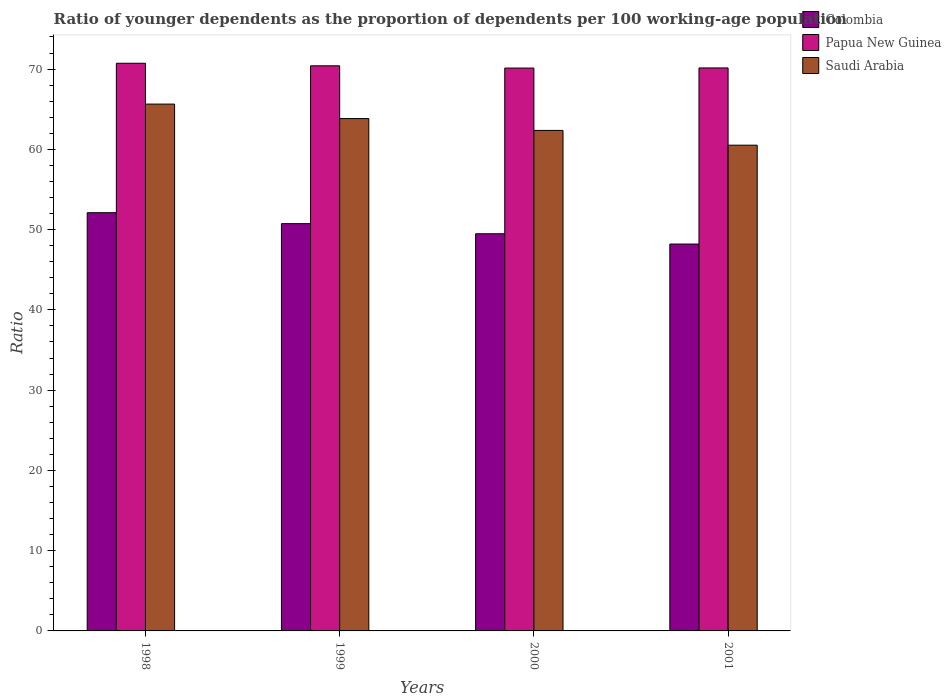How many groups of bars are there?
Your answer should be very brief. 4. Are the number of bars on each tick of the X-axis equal?
Your response must be concise. Yes. What is the label of the 2nd group of bars from the left?
Ensure brevity in your answer.  1999. What is the age dependency ratio(young) in Saudi Arabia in 2000?
Keep it short and to the point. 62.36. Across all years, what is the maximum age dependency ratio(young) in Saudi Arabia?
Your answer should be compact. 65.64. Across all years, what is the minimum age dependency ratio(young) in Saudi Arabia?
Offer a terse response. 60.52. In which year was the age dependency ratio(young) in Papua New Guinea maximum?
Ensure brevity in your answer.  1998. In which year was the age dependency ratio(young) in Saudi Arabia minimum?
Keep it short and to the point. 2001. What is the total age dependency ratio(young) in Saudi Arabia in the graph?
Provide a succinct answer. 252.34. What is the difference between the age dependency ratio(young) in Colombia in 2000 and that in 2001?
Provide a succinct answer. 1.28. What is the difference between the age dependency ratio(young) in Colombia in 2001 and the age dependency ratio(young) in Papua New Guinea in 1999?
Keep it short and to the point. -22.21. What is the average age dependency ratio(young) in Saudi Arabia per year?
Provide a short and direct response. 63.09. In the year 2001, what is the difference between the age dependency ratio(young) in Colombia and age dependency ratio(young) in Saudi Arabia?
Give a very brief answer. -12.32. What is the ratio of the age dependency ratio(young) in Papua New Guinea in 1999 to that in 2000?
Ensure brevity in your answer.  1. Is the age dependency ratio(young) in Saudi Arabia in 1998 less than that in 2000?
Give a very brief answer. No. What is the difference between the highest and the second highest age dependency ratio(young) in Saudi Arabia?
Provide a succinct answer. 1.8. What is the difference between the highest and the lowest age dependency ratio(young) in Papua New Guinea?
Ensure brevity in your answer.  0.6. In how many years, is the age dependency ratio(young) in Saudi Arabia greater than the average age dependency ratio(young) in Saudi Arabia taken over all years?
Offer a terse response. 2. What does the 2nd bar from the left in 1999 represents?
Provide a short and direct response. Papua New Guinea. What does the 2nd bar from the right in 1998 represents?
Keep it short and to the point. Papua New Guinea. Is it the case that in every year, the sum of the age dependency ratio(young) in Saudi Arabia and age dependency ratio(young) in Papua New Guinea is greater than the age dependency ratio(young) in Colombia?
Ensure brevity in your answer.  Yes. How many bars are there?
Keep it short and to the point. 12. How many years are there in the graph?
Provide a short and direct response. 4. How many legend labels are there?
Ensure brevity in your answer.  3. What is the title of the graph?
Offer a terse response. Ratio of younger dependents as the proportion of dependents per 100 working-age population. What is the label or title of the Y-axis?
Keep it short and to the point. Ratio. What is the Ratio of Colombia in 1998?
Provide a short and direct response. 52.11. What is the Ratio in Papua New Guinea in 1998?
Ensure brevity in your answer.  70.72. What is the Ratio in Saudi Arabia in 1998?
Keep it short and to the point. 65.64. What is the Ratio of Colombia in 1999?
Offer a terse response. 50.74. What is the Ratio in Papua New Guinea in 1999?
Make the answer very short. 70.41. What is the Ratio in Saudi Arabia in 1999?
Provide a short and direct response. 63.83. What is the Ratio in Colombia in 2000?
Your answer should be very brief. 49.48. What is the Ratio in Papua New Guinea in 2000?
Offer a terse response. 70.13. What is the Ratio of Saudi Arabia in 2000?
Offer a terse response. 62.36. What is the Ratio in Colombia in 2001?
Give a very brief answer. 48.2. What is the Ratio of Papua New Guinea in 2001?
Provide a short and direct response. 70.14. What is the Ratio in Saudi Arabia in 2001?
Offer a very short reply. 60.52. Across all years, what is the maximum Ratio of Colombia?
Your response must be concise. 52.11. Across all years, what is the maximum Ratio of Papua New Guinea?
Your response must be concise. 70.72. Across all years, what is the maximum Ratio in Saudi Arabia?
Make the answer very short. 65.64. Across all years, what is the minimum Ratio in Colombia?
Your answer should be very brief. 48.2. Across all years, what is the minimum Ratio in Papua New Guinea?
Make the answer very short. 70.13. Across all years, what is the minimum Ratio of Saudi Arabia?
Ensure brevity in your answer.  60.52. What is the total Ratio of Colombia in the graph?
Provide a short and direct response. 200.53. What is the total Ratio of Papua New Guinea in the graph?
Your answer should be very brief. 281.4. What is the total Ratio of Saudi Arabia in the graph?
Provide a short and direct response. 252.34. What is the difference between the Ratio of Colombia in 1998 and that in 1999?
Provide a short and direct response. 1.36. What is the difference between the Ratio in Papua New Guinea in 1998 and that in 1999?
Make the answer very short. 0.32. What is the difference between the Ratio in Saudi Arabia in 1998 and that in 1999?
Your response must be concise. 1.8. What is the difference between the Ratio in Colombia in 1998 and that in 2000?
Make the answer very short. 2.62. What is the difference between the Ratio in Papua New Guinea in 1998 and that in 2000?
Ensure brevity in your answer.  0.6. What is the difference between the Ratio of Saudi Arabia in 1998 and that in 2000?
Provide a succinct answer. 3.28. What is the difference between the Ratio of Colombia in 1998 and that in 2001?
Your answer should be compact. 3.91. What is the difference between the Ratio in Papua New Guinea in 1998 and that in 2001?
Make the answer very short. 0.58. What is the difference between the Ratio of Saudi Arabia in 1998 and that in 2001?
Give a very brief answer. 5.12. What is the difference between the Ratio of Colombia in 1999 and that in 2000?
Offer a very short reply. 1.26. What is the difference between the Ratio of Papua New Guinea in 1999 and that in 2000?
Provide a short and direct response. 0.28. What is the difference between the Ratio of Saudi Arabia in 1999 and that in 2000?
Offer a very short reply. 1.48. What is the difference between the Ratio in Colombia in 1999 and that in 2001?
Provide a succinct answer. 2.54. What is the difference between the Ratio of Papua New Guinea in 1999 and that in 2001?
Ensure brevity in your answer.  0.27. What is the difference between the Ratio in Saudi Arabia in 1999 and that in 2001?
Make the answer very short. 3.32. What is the difference between the Ratio in Colombia in 2000 and that in 2001?
Give a very brief answer. 1.28. What is the difference between the Ratio in Papua New Guinea in 2000 and that in 2001?
Give a very brief answer. -0.01. What is the difference between the Ratio of Saudi Arabia in 2000 and that in 2001?
Keep it short and to the point. 1.84. What is the difference between the Ratio in Colombia in 1998 and the Ratio in Papua New Guinea in 1999?
Provide a short and direct response. -18.3. What is the difference between the Ratio of Colombia in 1998 and the Ratio of Saudi Arabia in 1999?
Ensure brevity in your answer.  -11.73. What is the difference between the Ratio in Papua New Guinea in 1998 and the Ratio in Saudi Arabia in 1999?
Provide a succinct answer. 6.89. What is the difference between the Ratio in Colombia in 1998 and the Ratio in Papua New Guinea in 2000?
Provide a short and direct response. -18.02. What is the difference between the Ratio in Colombia in 1998 and the Ratio in Saudi Arabia in 2000?
Your response must be concise. -10.25. What is the difference between the Ratio of Papua New Guinea in 1998 and the Ratio of Saudi Arabia in 2000?
Your response must be concise. 8.37. What is the difference between the Ratio in Colombia in 1998 and the Ratio in Papua New Guinea in 2001?
Your answer should be compact. -18.04. What is the difference between the Ratio of Colombia in 1998 and the Ratio of Saudi Arabia in 2001?
Offer a terse response. -8.41. What is the difference between the Ratio in Papua New Guinea in 1998 and the Ratio in Saudi Arabia in 2001?
Give a very brief answer. 10.21. What is the difference between the Ratio of Colombia in 1999 and the Ratio of Papua New Guinea in 2000?
Provide a succinct answer. -19.39. What is the difference between the Ratio in Colombia in 1999 and the Ratio in Saudi Arabia in 2000?
Provide a succinct answer. -11.62. What is the difference between the Ratio in Papua New Guinea in 1999 and the Ratio in Saudi Arabia in 2000?
Give a very brief answer. 8.05. What is the difference between the Ratio in Colombia in 1999 and the Ratio in Papua New Guinea in 2001?
Keep it short and to the point. -19.4. What is the difference between the Ratio in Colombia in 1999 and the Ratio in Saudi Arabia in 2001?
Your response must be concise. -9.78. What is the difference between the Ratio in Papua New Guinea in 1999 and the Ratio in Saudi Arabia in 2001?
Give a very brief answer. 9.89. What is the difference between the Ratio of Colombia in 2000 and the Ratio of Papua New Guinea in 2001?
Ensure brevity in your answer.  -20.66. What is the difference between the Ratio in Colombia in 2000 and the Ratio in Saudi Arabia in 2001?
Your response must be concise. -11.04. What is the difference between the Ratio of Papua New Guinea in 2000 and the Ratio of Saudi Arabia in 2001?
Your response must be concise. 9.61. What is the average Ratio in Colombia per year?
Offer a very short reply. 50.13. What is the average Ratio in Papua New Guinea per year?
Offer a terse response. 70.35. What is the average Ratio in Saudi Arabia per year?
Provide a succinct answer. 63.09. In the year 1998, what is the difference between the Ratio in Colombia and Ratio in Papua New Guinea?
Ensure brevity in your answer.  -18.62. In the year 1998, what is the difference between the Ratio of Colombia and Ratio of Saudi Arabia?
Give a very brief answer. -13.53. In the year 1998, what is the difference between the Ratio of Papua New Guinea and Ratio of Saudi Arabia?
Offer a terse response. 5.09. In the year 1999, what is the difference between the Ratio of Colombia and Ratio of Papua New Guinea?
Offer a terse response. -19.67. In the year 1999, what is the difference between the Ratio in Colombia and Ratio in Saudi Arabia?
Offer a terse response. -13.09. In the year 1999, what is the difference between the Ratio in Papua New Guinea and Ratio in Saudi Arabia?
Give a very brief answer. 6.57. In the year 2000, what is the difference between the Ratio in Colombia and Ratio in Papua New Guinea?
Keep it short and to the point. -20.64. In the year 2000, what is the difference between the Ratio in Colombia and Ratio in Saudi Arabia?
Ensure brevity in your answer.  -12.88. In the year 2000, what is the difference between the Ratio in Papua New Guinea and Ratio in Saudi Arabia?
Make the answer very short. 7.77. In the year 2001, what is the difference between the Ratio in Colombia and Ratio in Papua New Guinea?
Keep it short and to the point. -21.94. In the year 2001, what is the difference between the Ratio of Colombia and Ratio of Saudi Arabia?
Ensure brevity in your answer.  -12.32. In the year 2001, what is the difference between the Ratio in Papua New Guinea and Ratio in Saudi Arabia?
Offer a terse response. 9.62. What is the ratio of the Ratio of Colombia in 1998 to that in 1999?
Make the answer very short. 1.03. What is the ratio of the Ratio of Saudi Arabia in 1998 to that in 1999?
Ensure brevity in your answer.  1.03. What is the ratio of the Ratio of Colombia in 1998 to that in 2000?
Give a very brief answer. 1.05. What is the ratio of the Ratio of Papua New Guinea in 1998 to that in 2000?
Provide a short and direct response. 1.01. What is the ratio of the Ratio of Saudi Arabia in 1998 to that in 2000?
Offer a very short reply. 1.05. What is the ratio of the Ratio of Colombia in 1998 to that in 2001?
Your answer should be compact. 1.08. What is the ratio of the Ratio in Papua New Guinea in 1998 to that in 2001?
Provide a short and direct response. 1.01. What is the ratio of the Ratio in Saudi Arabia in 1998 to that in 2001?
Ensure brevity in your answer.  1.08. What is the ratio of the Ratio in Colombia in 1999 to that in 2000?
Your response must be concise. 1.03. What is the ratio of the Ratio of Papua New Guinea in 1999 to that in 2000?
Your answer should be compact. 1. What is the ratio of the Ratio of Saudi Arabia in 1999 to that in 2000?
Provide a succinct answer. 1.02. What is the ratio of the Ratio in Colombia in 1999 to that in 2001?
Keep it short and to the point. 1.05. What is the ratio of the Ratio in Papua New Guinea in 1999 to that in 2001?
Offer a terse response. 1. What is the ratio of the Ratio of Saudi Arabia in 1999 to that in 2001?
Offer a terse response. 1.05. What is the ratio of the Ratio in Colombia in 2000 to that in 2001?
Your answer should be compact. 1.03. What is the ratio of the Ratio of Papua New Guinea in 2000 to that in 2001?
Give a very brief answer. 1. What is the ratio of the Ratio in Saudi Arabia in 2000 to that in 2001?
Your response must be concise. 1.03. What is the difference between the highest and the second highest Ratio in Colombia?
Your answer should be compact. 1.36. What is the difference between the highest and the second highest Ratio in Papua New Guinea?
Your response must be concise. 0.32. What is the difference between the highest and the second highest Ratio in Saudi Arabia?
Ensure brevity in your answer.  1.8. What is the difference between the highest and the lowest Ratio in Colombia?
Give a very brief answer. 3.91. What is the difference between the highest and the lowest Ratio in Papua New Guinea?
Make the answer very short. 0.6. What is the difference between the highest and the lowest Ratio in Saudi Arabia?
Your answer should be compact. 5.12. 